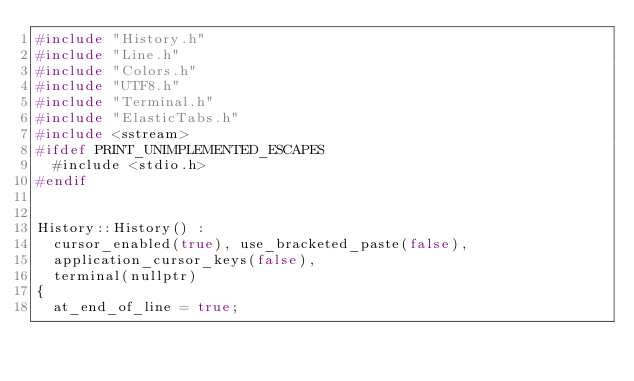<code> <loc_0><loc_0><loc_500><loc_500><_C++_>#include "History.h"
#include "Line.h"
#include "Colors.h"
#include "UTF8.h"
#include "Terminal.h"
#include "ElasticTabs.h"
#include <sstream>
#ifdef PRINT_UNIMPLEMENTED_ESCAPES
	#include <stdio.h>
#endif


History::History() :
	cursor_enabled(true), use_bracketed_paste(false),
	application_cursor_keys(false),
	terminal(nullptr)
{
	at_end_of_line = true;</code> 